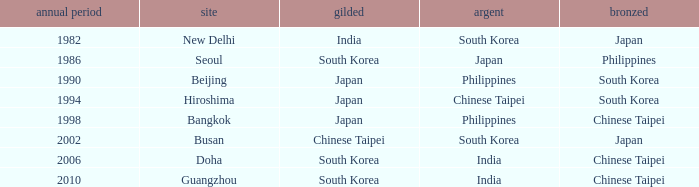How many years has Japan won silver? 1986.0. 